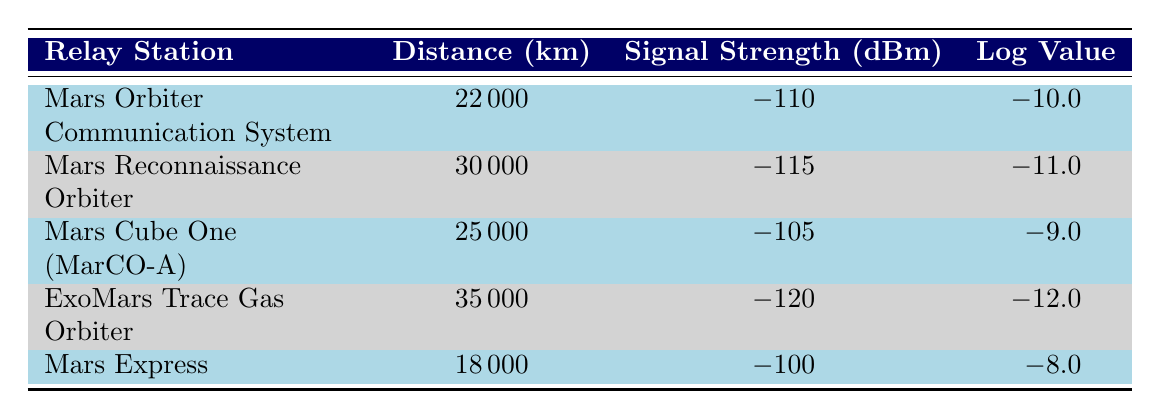What is the signal strength of the Mars Express relay station? According to the table, the signal strength for the Mars Express relay station is shown in the corresponding column, and it states -100 dBm.
Answer: -100 dBm Which relay station has the farthest distance from the rover? By examining the Distance column, the relay station with the maximum value is the ExoMars Trace Gas Orbiter at 35000 km.
Answer: ExoMars Trace Gas Orbiter What is the logarithmic value of the signal strength for the Mars Reconnaissance Orbiter? The table includes the logarithmic values in the relevant column for each relay station. For Mars Reconnaissance Orbiter, it is -11.0.
Answer: -11.0 How many relay stations have a signal strength of -110 dBm or lower? To find the answer, we check the Signal Strength column for values at or below -110 dBm. There are 4 relay stations: Mars Orbiter Communication System, Mars Reconnaissance Orbiter, ExoMars Trace Gas Orbiter, and Mars Express.
Answer: 4 What is the average distance of all the relay stations listed? To find the average distance, first add all the distances: 22000 + 30000 + 25000 + 35000 + 18000 = 130000 km. Then divide by the amount of stations, which is 5: 130000/5 = 26000 km.
Answer: 26000 km Is the signal strength of Mars Cube One (MarCO-A) stronger than -110 dBm? Comparing the signal strength of Mars Cube One (MarCO-A), which is -105 dBm, with -110 dBm shows that -105 dBm is indeed stronger.
Answer: Yes What is the difference in signal strength between the strongest and weakest relay stations? The strongest signal is -100 dBm (Mars Express) and the weakest is -120 dBm (ExoMars Trace Gas Orbiter). The difference is -100 - (-120) = 20 dBm.
Answer: 20 dBm Which relay station has a more negative logarithmic value, the Mars Orbiter Communication System or Mars Cube One (MarCO-A)? The logarithmic values for these stations are -10.0 and -9.0 respectively. Since -10.0 is more negative than -9.0, Mars Orbiter Communication System has the more negative value.
Answer: Mars Orbiter Communication System How many relay stations are positioned at distances greater than 25000 km? Checking the distance values in the table, the stations with distances greater than 25000 km are Mars Reconnaissance Orbiter, ExoMars Trace Gas Orbiter, and Mars Cube One (MarCO-A), which totals 3 stations.
Answer: 3 